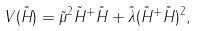<formula> <loc_0><loc_0><loc_500><loc_500>V ( \tilde { H } ) = \tilde { \mu } ^ { 2 } \tilde { H } ^ { + } \tilde { H } + \tilde { \lambda } ( \tilde { H } ^ { + } \tilde { H } ) ^ { 2 } ,</formula> 